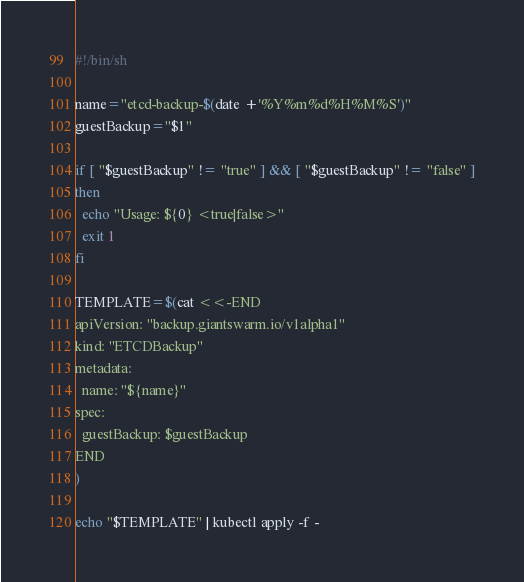Convert code to text. <code><loc_0><loc_0><loc_500><loc_500><_Bash_>#!/bin/sh

name="etcd-backup-$(date +'%Y%m%d%H%M%S')"
guestBackup="$1"

if [ "$guestBackup" != "true" ] && [ "$guestBackup" != "false" ]
then
  echo "Usage: ${0} <true|false>"
  exit 1
fi

TEMPLATE=$(cat <<-END
apiVersion: "backup.giantswarm.io/v1alpha1"
kind: "ETCDBackup"
metadata:
  name: "${name}"
spec:
  guestBackup: $guestBackup
END
)

echo "$TEMPLATE" | kubectl apply -f -
</code> 